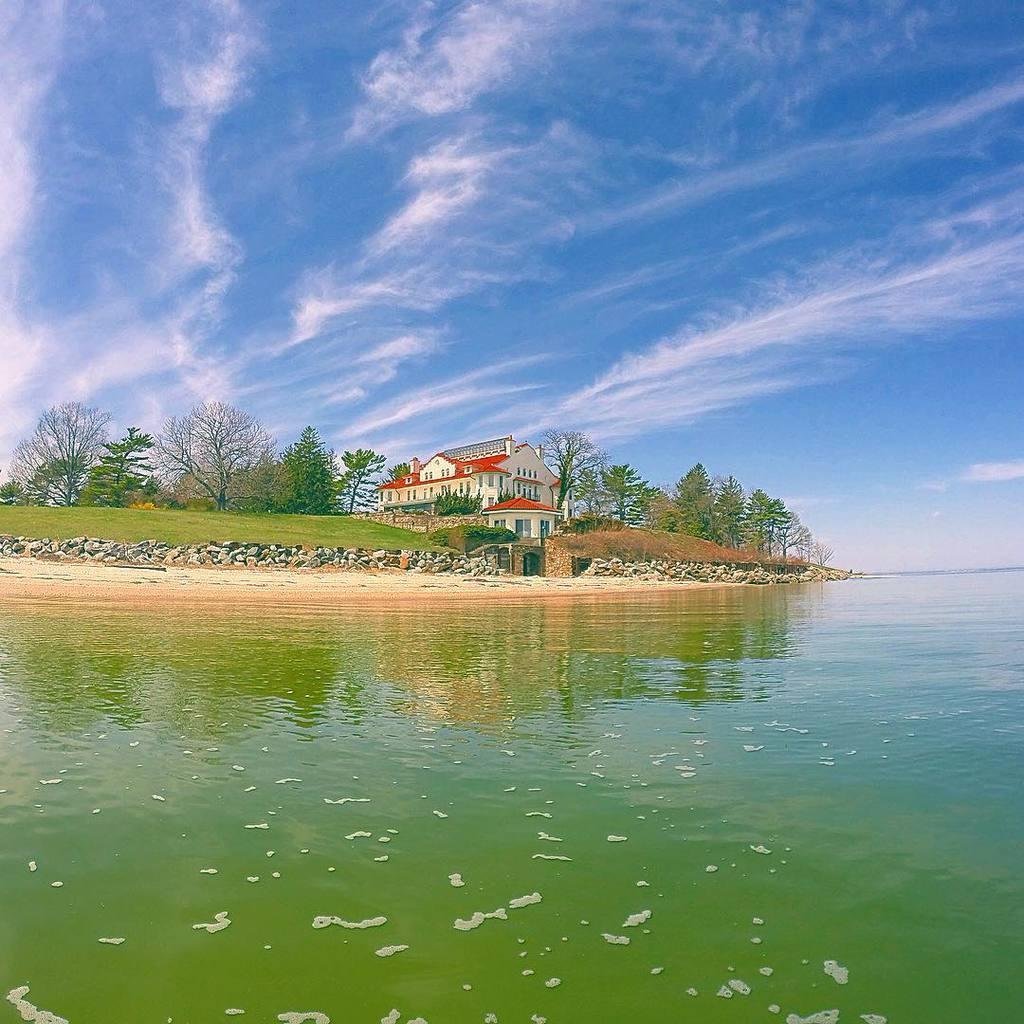What is the main feature of the image? The main feature of the image is a water surface. What else can be seen in the image besides the water surface? There are stones, a building, trees, and clouds visible in the image. Can you describe the building in the image? The building in the image is a structure with walls and a roof. What is visible in the sky at the top of the image? Clouds are visible in the sky at the top of the image. How many hot plates are visible on the water surface in the image? There are no hot plates visible on the water surface in the image. What type of cars can be seen driving through the water in the image? There are no cars visible in the image, and the water surface is not being driven through. 